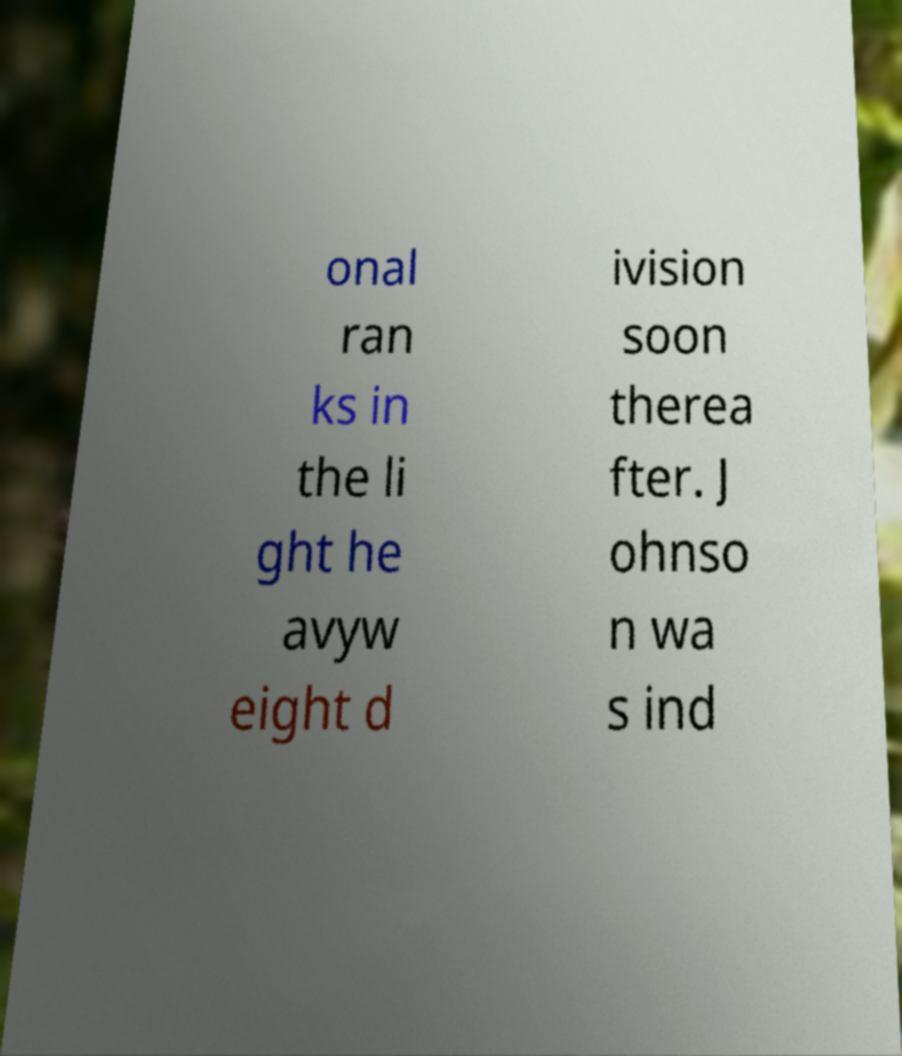Please identify and transcribe the text found in this image. onal ran ks in the li ght he avyw eight d ivision soon therea fter. J ohnso n wa s ind 